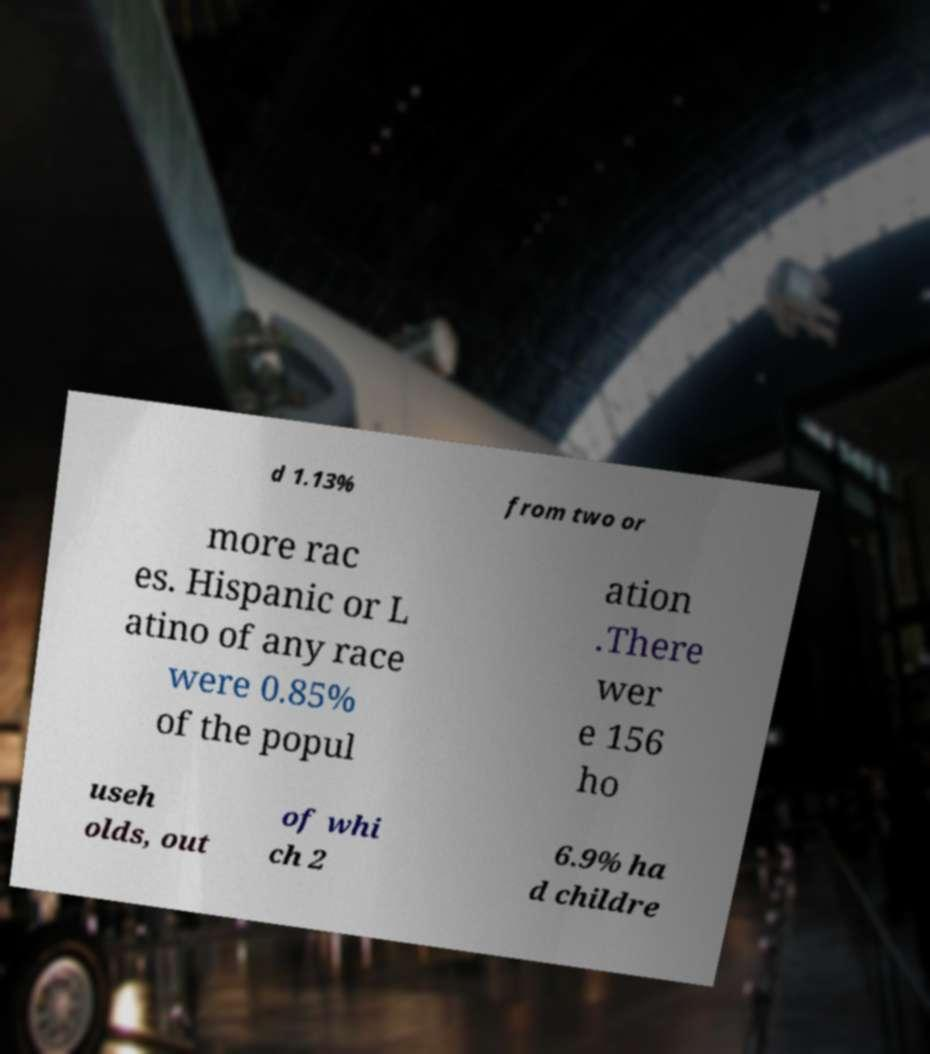Could you assist in decoding the text presented in this image and type it out clearly? d 1.13% from two or more rac es. Hispanic or L atino of any race were 0.85% of the popul ation .There wer e 156 ho useh olds, out of whi ch 2 6.9% ha d childre 